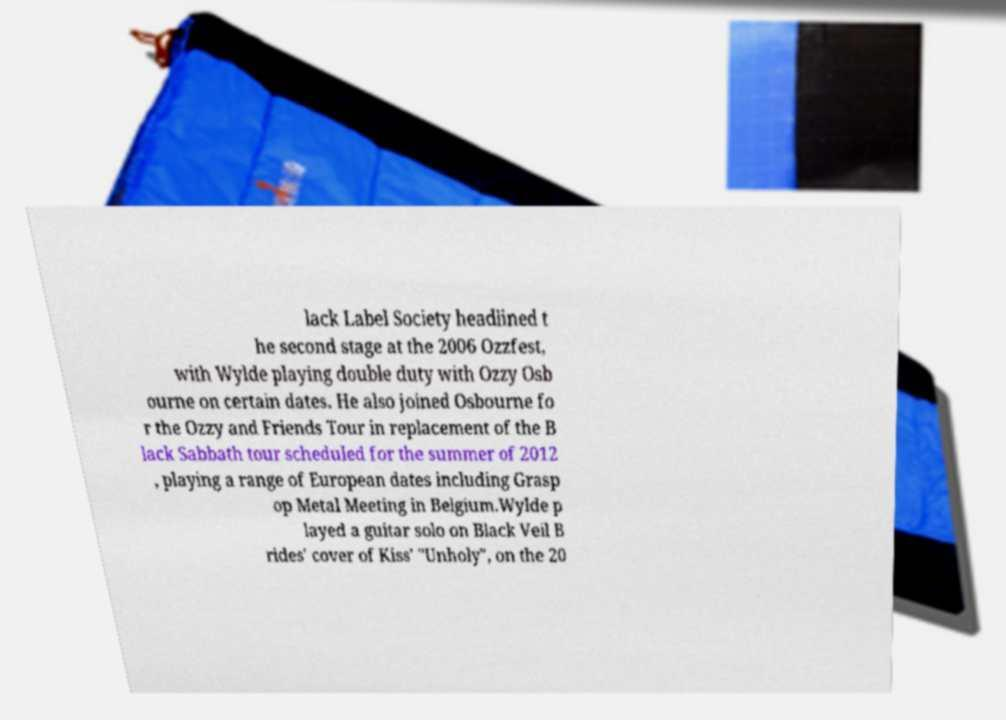I need the written content from this picture converted into text. Can you do that? lack Label Society headlined t he second stage at the 2006 Ozzfest, with Wylde playing double duty with Ozzy Osb ourne on certain dates. He also joined Osbourne fo r the Ozzy and Friends Tour in replacement of the B lack Sabbath tour scheduled for the summer of 2012 , playing a range of European dates including Grasp op Metal Meeting in Belgium.Wylde p layed a guitar solo on Black Veil B rides' cover of Kiss' "Unholy", on the 20 